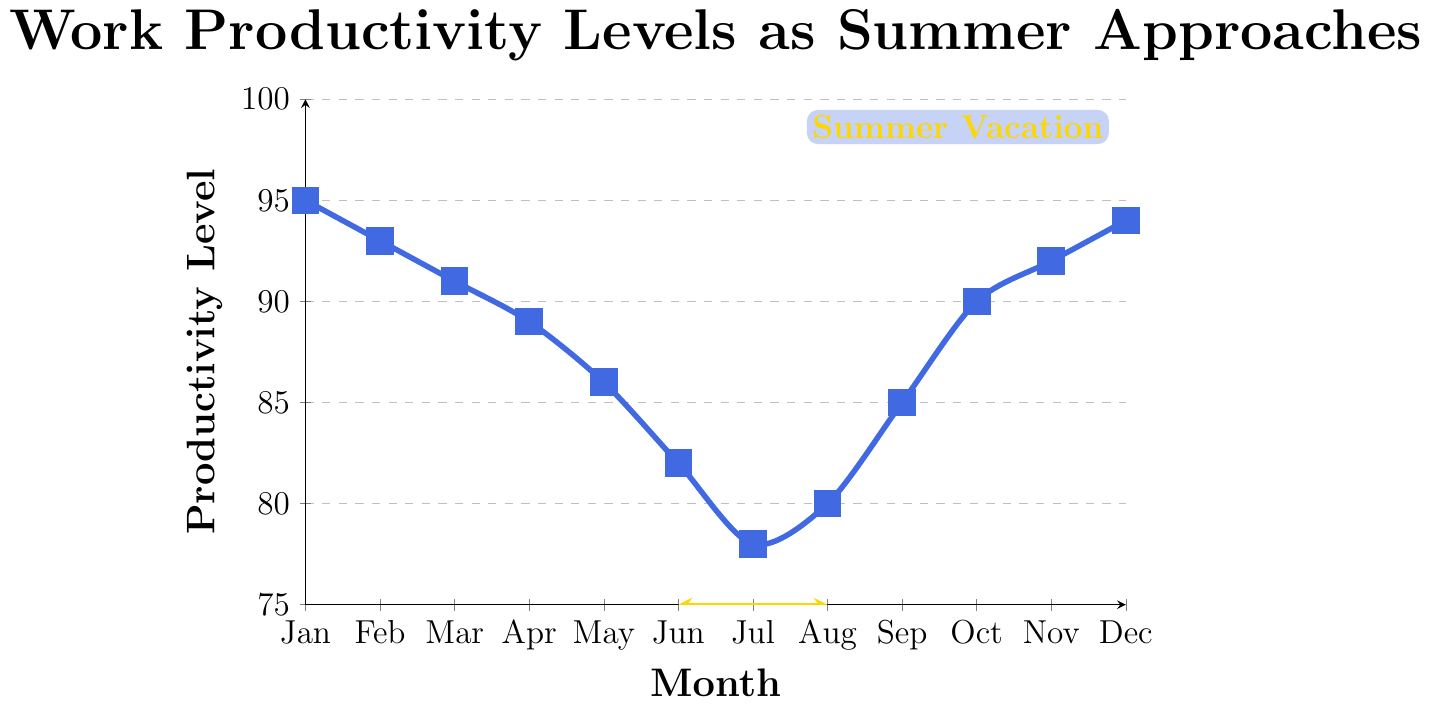How does productivity change from June to July? From the figure, productivity drops from 82 in June to 78 in July. This can be observed by noting the decrease in the line's height between these two months.
Answer: It decreases Which month has the lowest productivity level, and what is the value? The lowest point on the plot is in July, where the productivity level is 78. This is identified by looking at the smallest y-coordinate.
Answer: July, 78 How much does productivity drop from January to June? The productivity level in January is 95, and in June it is 82. The drop is calculated by subtracting the June value from the January value: 95 - 82 = 13.
Answer: 13 Is there any month where productivity increases as summer approaches? The data shows a slight increase in productivity between July and August, from 78 to 80. This can be seen in the upward trend between these months.
Answer: Yes, between July and August What is the average productivity level from January to June? The productivity levels from January to June are 95, 93, 91, 89, 86, 82. Adding these values gives 536, and there are 6 months, so the average is 536/6 = 89.33.
Answer: 89.33 In which months does productivity level return to 90 or above after dropping below 90? After falling below 90, productivity returns to 90 in October and stays above in November and December. This is observed from the y-values in those months.
Answer: October, November, December How does the overall trend of productivity change as summer approaches? The overall trend shows a decline in productivity from January to July, hitting the lowest in July, followed by a slight rise again in August. This can be seen by the downward slope of the line until July and then a small upward trend.
Answer: It declines, then slightly rises in August Compare productivity levels between the beginning of the year (January) and the end of the year (December). The productivity level is 95 in January and 94 in December. This small difference of just 1 indicates nearly identical productivity levels at these two times of the year.
Answer: Almost the same, with a small decrease of 1 What is the difference in productivity levels between the highest and lowest months? The highest productivity is in January at 95, and the lowest is in July at 78. The difference is 95 - 78 = 17.
Answer: 17 What months have a productivity level equal to 90 or above, and how many are there? From the plot, the months with productivity levels of 90 or above are January, February, November, December, and October. There are 5 such months.
Answer: January, February, November, December, October; 5 